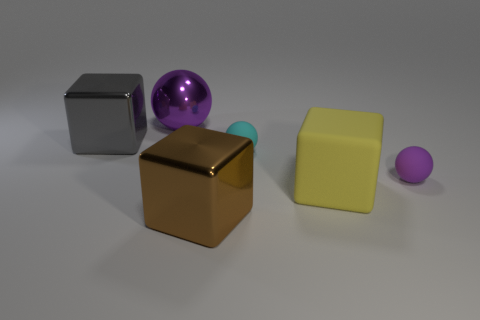Are there more small rubber spheres in front of the large gray thing than large purple objects?
Your answer should be compact. Yes. Are there the same number of tiny purple objects that are behind the gray cube and spheres right of the brown thing?
Offer a terse response. No. Is there a large purple metal thing that is behind the big metallic cube that is in front of the large gray shiny block?
Ensure brevity in your answer.  Yes. What is the shape of the tiny cyan matte thing?
Your answer should be compact. Sphere. There is a thing that is the same color as the large metallic ball; what size is it?
Your answer should be compact. Small. How big is the cube that is behind the small thing behind the tiny purple matte sphere?
Ensure brevity in your answer.  Large. How big is the purple thing in front of the gray thing?
Keep it short and to the point. Small. Are there fewer blocks that are on the left side of the big gray thing than purple rubber things behind the tiny cyan object?
Your answer should be compact. No. What color is the big rubber cube?
Keep it short and to the point. Yellow. Is there a matte ball that has the same color as the metallic ball?
Your answer should be very brief. Yes. 